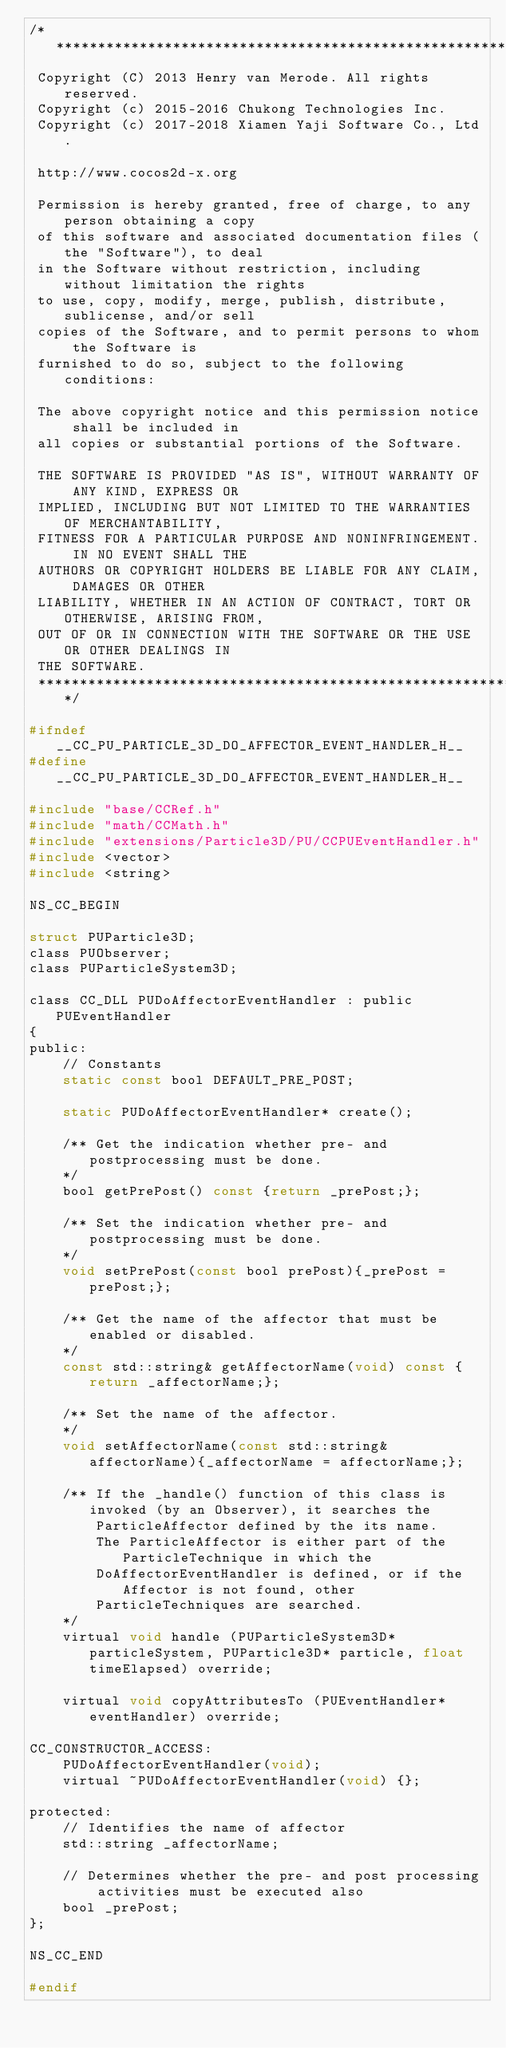Convert code to text. <code><loc_0><loc_0><loc_500><loc_500><_C_>/****************************************************************************
 Copyright (C) 2013 Henry van Merode. All rights reserved.
 Copyright (c) 2015-2016 Chukong Technologies Inc.
 Copyright (c) 2017-2018 Xiamen Yaji Software Co., Ltd.
 
 http://www.cocos2d-x.org
 
 Permission is hereby granted, free of charge, to any person obtaining a copy
 of this software and associated documentation files (the "Software"), to deal
 in the Software without restriction, including without limitation the rights
 to use, copy, modify, merge, publish, distribute, sublicense, and/or sell
 copies of the Software, and to permit persons to whom the Software is
 furnished to do so, subject to the following conditions:
 
 The above copyright notice and this permission notice shall be included in
 all copies or substantial portions of the Software.
 
 THE SOFTWARE IS PROVIDED "AS IS", WITHOUT WARRANTY OF ANY KIND, EXPRESS OR
 IMPLIED, INCLUDING BUT NOT LIMITED TO THE WARRANTIES OF MERCHANTABILITY,
 FITNESS FOR A PARTICULAR PURPOSE AND NONINFRINGEMENT. IN NO EVENT SHALL THE
 AUTHORS OR COPYRIGHT HOLDERS BE LIABLE FOR ANY CLAIM, DAMAGES OR OTHER
 LIABILITY, WHETHER IN AN ACTION OF CONTRACT, TORT OR OTHERWISE, ARISING FROM,
 OUT OF OR IN CONNECTION WITH THE SOFTWARE OR THE USE OR OTHER DEALINGS IN
 THE SOFTWARE.
 ****************************************************************************/

#ifndef __CC_PU_PARTICLE_3D_DO_AFFECTOR_EVENT_HANDLER_H__
#define __CC_PU_PARTICLE_3D_DO_AFFECTOR_EVENT_HANDLER_H__

#include "base/CCRef.h"
#include "math/CCMath.h"
#include "extensions/Particle3D/PU/CCPUEventHandler.h"
#include <vector>
#include <string>

NS_CC_BEGIN

struct PUParticle3D;
class PUObserver;
class PUParticleSystem3D;

class CC_DLL PUDoAffectorEventHandler : public PUEventHandler
{
public:
    // Constants
    static const bool DEFAULT_PRE_POST;

    static PUDoAffectorEventHandler* create();

    /** Get the indication whether pre- and postprocessing must be done.
    */
    bool getPrePost() const {return _prePost;};

    /** Set the indication whether pre- and postprocessing must be done.
    */
    void setPrePost(const bool prePost){_prePost = prePost;};

    /** Get the name of the affector that must be enabled or disabled.
    */
    const std::string& getAffectorName(void) const {return _affectorName;};

    /** Set the name of the affector.
    */
    void setAffectorName(const std::string& affectorName){_affectorName = affectorName;};

    /** If the _handle() function of this class is invoked (by an Observer), it searches the 
        ParticleAffector defined by the its name. 
        The ParticleAffector is either part of the ParticleTechnique in which the 
        DoAffectorEventHandler is defined, or if the Affector is not found, other 
        ParticleTechniques are searched.
    */
    virtual void handle (PUParticleSystem3D* particleSystem, PUParticle3D* particle, float timeElapsed) override;

    virtual void copyAttributesTo (PUEventHandler* eventHandler) override;

CC_CONSTRUCTOR_ACCESS:
    PUDoAffectorEventHandler(void);
    virtual ~PUDoAffectorEventHandler(void) {};

protected:
    // Identifies the name of affector
    std::string _affectorName;

    // Determines whether the pre- and post processing activities must be executed also
    bool _prePost;
};

NS_CC_END

#endif
</code> 